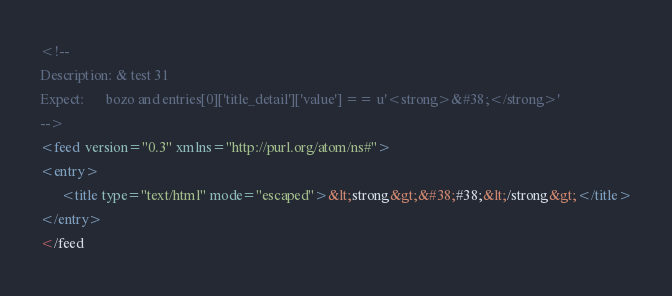<code> <loc_0><loc_0><loc_500><loc_500><_XML_><!--
Description: & test 31
Expect:      bozo and entries[0]['title_detail']['value'] == u'<strong>&#38;</strong>'
-->
<feed version="0.3" xmlns="http://purl.org/atom/ns#">
<entry>
	  <title type="text/html" mode="escaped">&lt;strong&gt;&#38;#38;&lt;/strong&gt;</title>
</entry>
</feed</code> 